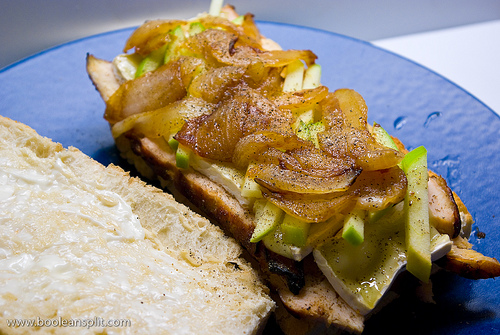Please extract the text content from this image. ww.booleansplit.com 